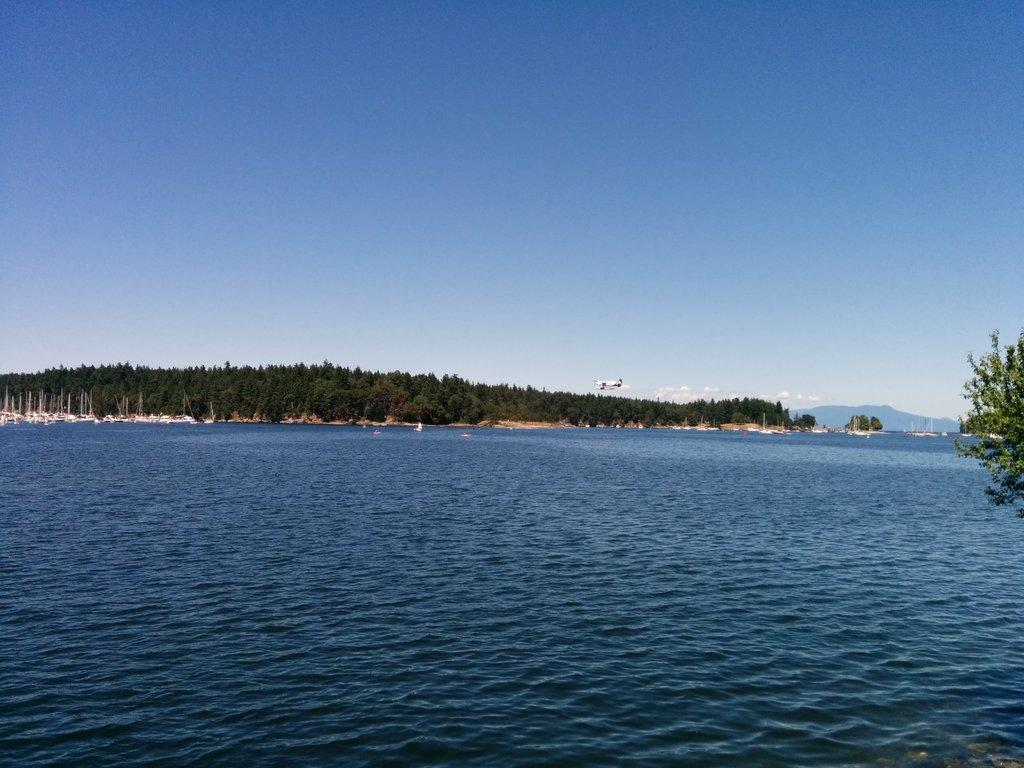What type of vegetation can be seen in the image? There are trees in the image. What geographical feature is present in the image? There is a hill in the image. What type of watercraft can be seen on the river in the image? There are boats on the surface of the river in the image. What part of the natural environment is visible in the image? The sky is visible in the image. Are there any dinosaurs visible in the image? No, there are no dinosaurs present in the image. What book is being read by the trees in the image? There is no book or reading activity depicted in the image; it features trees, a hill, boats, and the sky. 